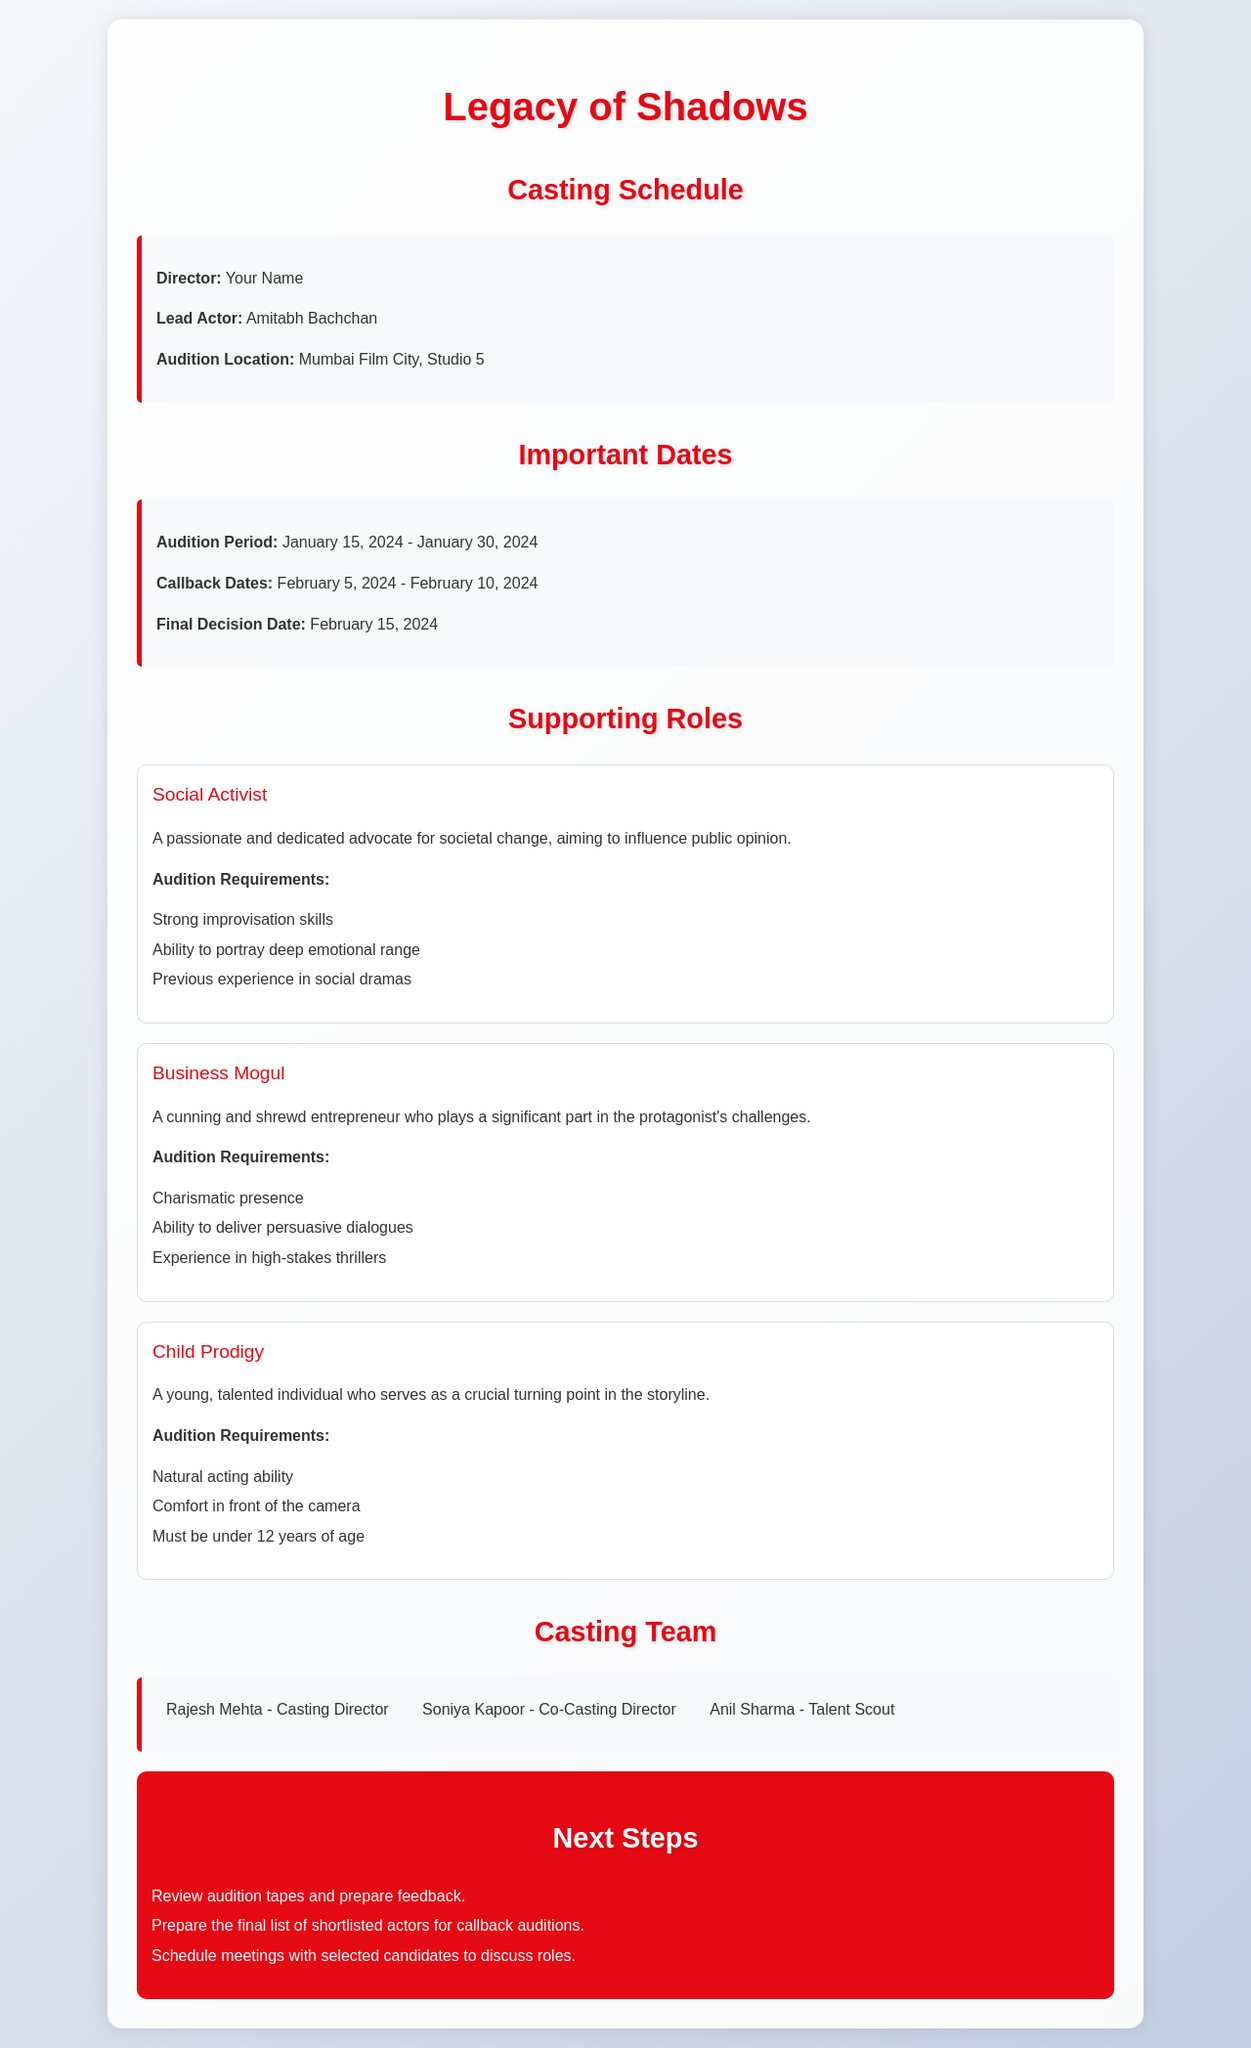What is the title of the film? The title of the film is mentioned at the top of the document as "Legacy of Shadows."
Answer: Legacy of Shadows What is the audition period? The audition period is specified in the document as running from January 15, 2024 to January 30, 2024.
Answer: January 15, 2024 - January 30, 2024 Who is the lead actor? The document clearly states that Amitabh Bachchan is the lead actor for the film.
Answer: Amitabh Bachchan When is the final decision date? The final decision date is listed as February 15, 2024 in the important dates section.
Answer: February 15, 2024 What role requires strong improvisation skills? The document outlines the requirements of the Social Activist role, which includes strong improvisation skills.
Answer: Social Activist What is a requirement for the Child Prodigy role? The requirement for the Child Prodigy role is specified as needing to be under 12 years of age.
Answer: Under 12 years of age Who is the casting director? The document identifies Rajesh Mehta as the casting director.
Answer: Rajesh Mehta What are the next steps after auditions? The next steps include reviewing audition tapes and preparing feedback.
Answer: Review audition tapes and prepare feedback When are the callback dates? The callback dates are provided as February 5, 2024 to February 10, 2024.
Answer: February 5, 2024 - February 10, 2024 